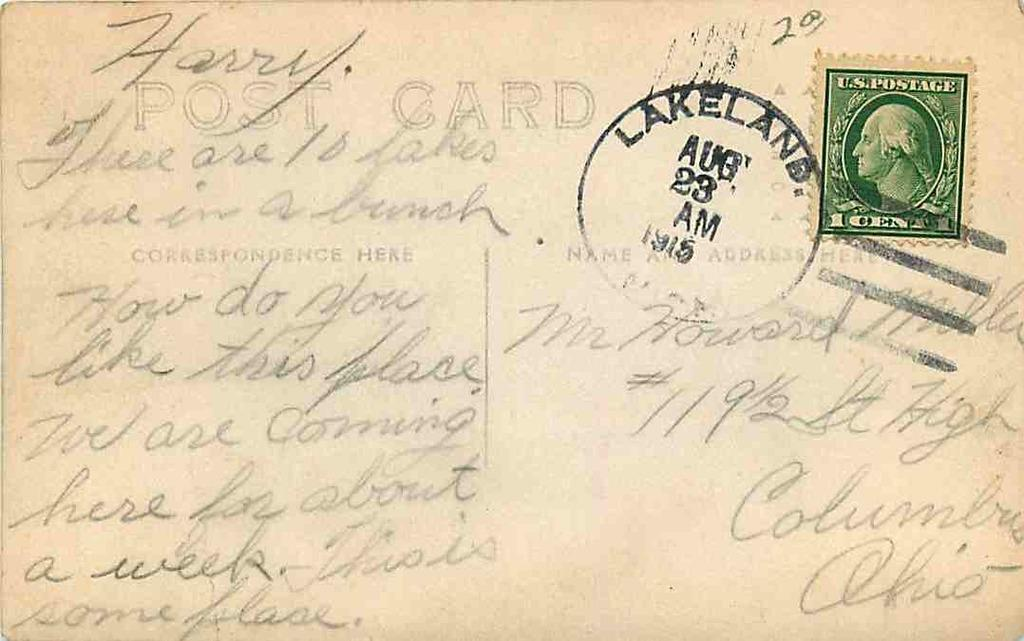Provide a one-sentence caption for the provided image. A postcard written to Harry around August 1915. 